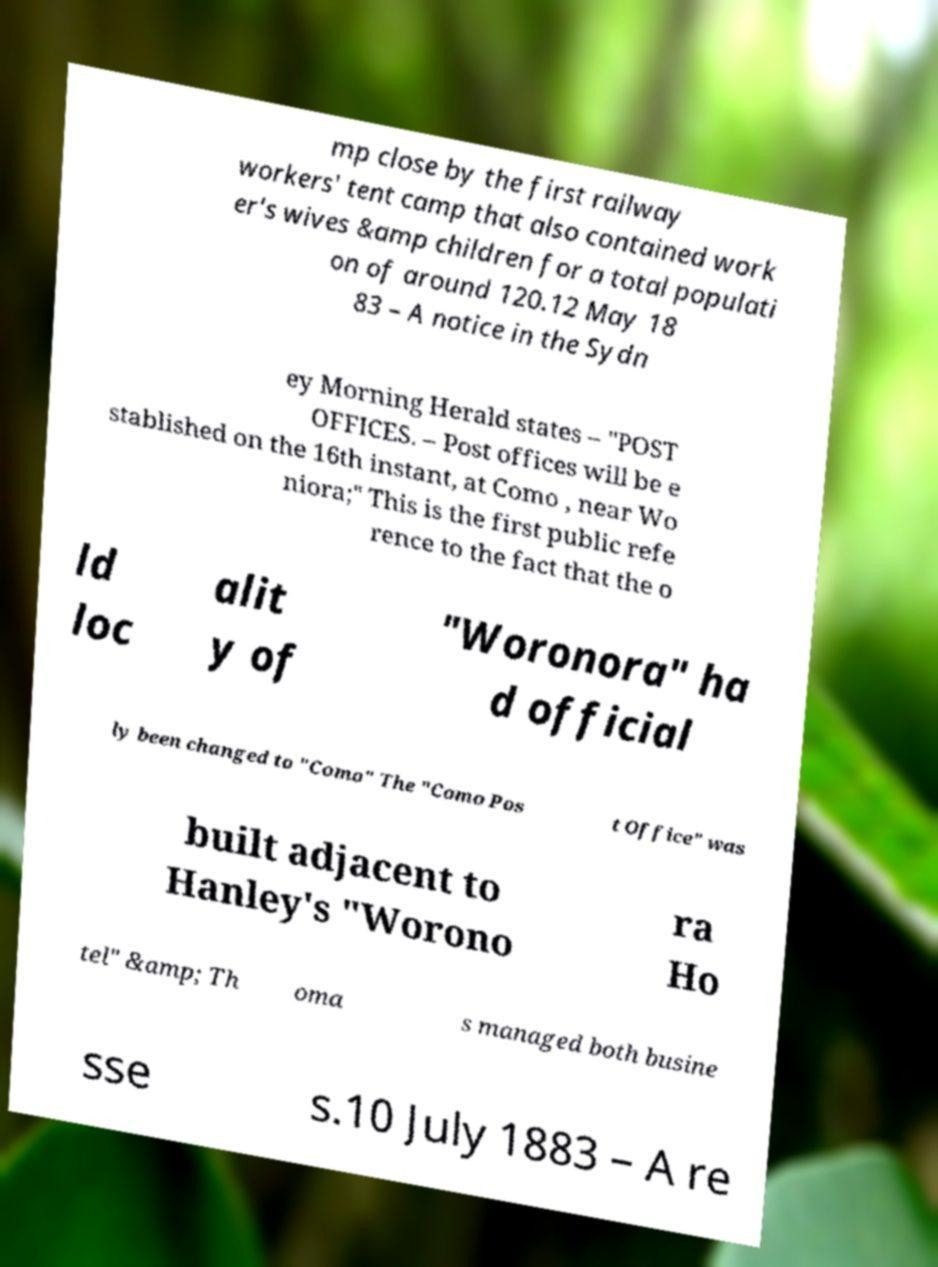For documentation purposes, I need the text within this image transcribed. Could you provide that? mp close by the first railway workers' tent camp that also contained work er's wives &amp children for a total populati on of around 120.12 May 18 83 – A notice in the Sydn ey Morning Herald states – "POST OFFICES. – Post offices will be e stablished on the 16th instant, at Como , near Wo niora;" This is the first public refe rence to the fact that the o ld loc alit y of "Woronora" ha d official ly been changed to "Como" The "Como Pos t Office" was built adjacent to Hanley's "Worono ra Ho tel" &amp; Th oma s managed both busine sse s.10 July 1883 – A re 